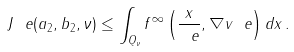Convert formula to latex. <formula><loc_0><loc_0><loc_500><loc_500>J _ { \ } e ( a _ { 2 } , b _ { 2 } , \nu ) \leq \int _ { Q _ { \nu } } f ^ { \infty } \left ( \frac { x } { \ e } , \nabla v _ { \ } e \right ) d x \, .</formula> 